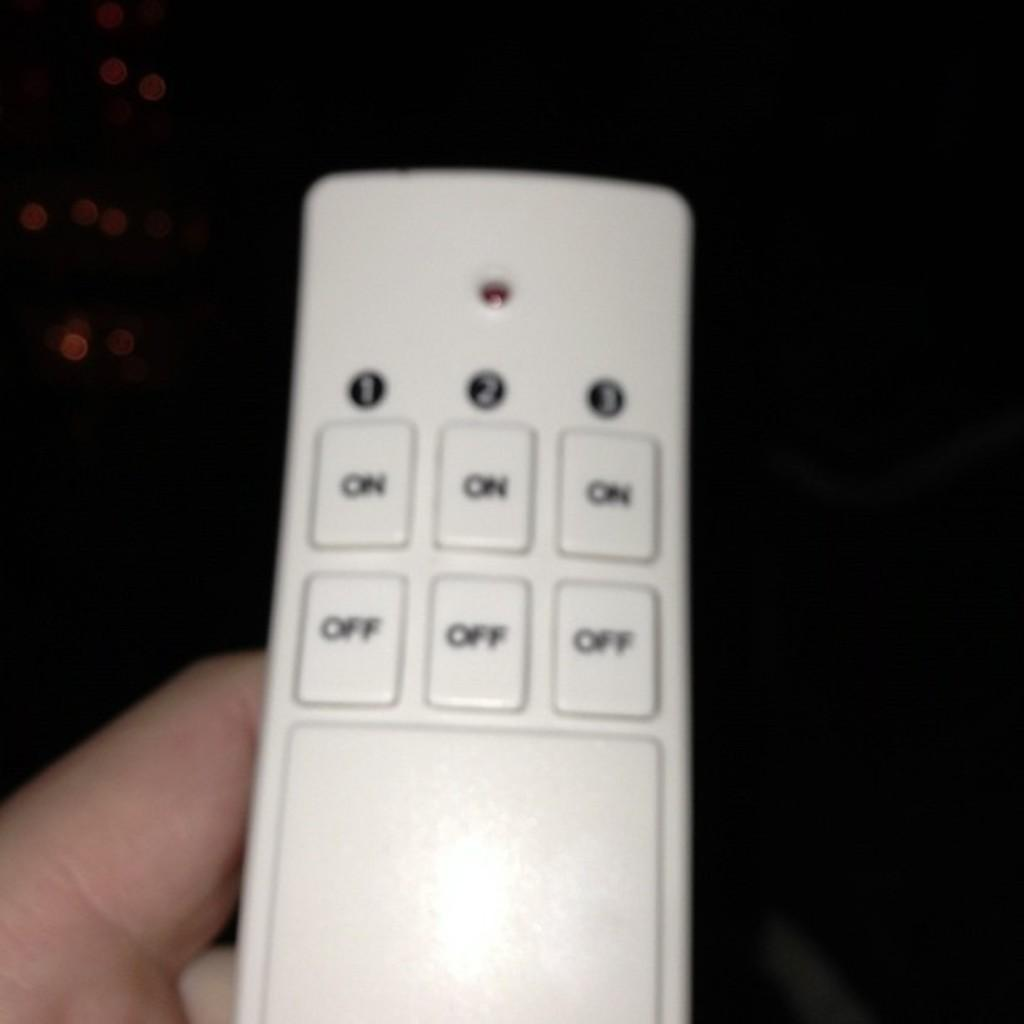<image>
Share a concise interpretation of the image provided. A multi controlling remote with 3 On and Off buttons. 